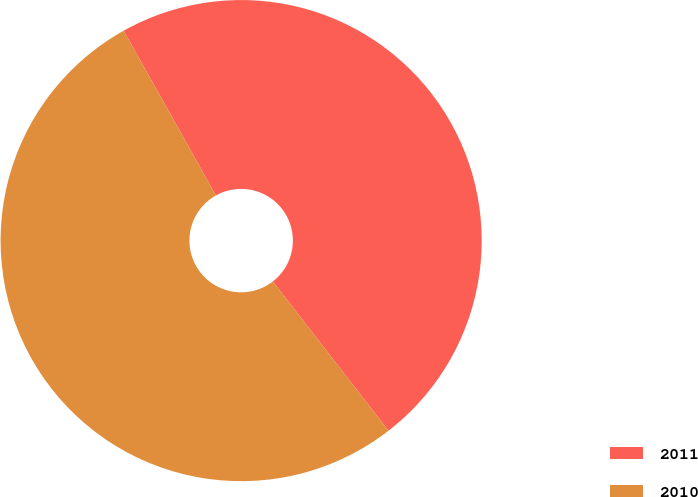Convert chart. <chart><loc_0><loc_0><loc_500><loc_500><pie_chart><fcel>2011<fcel>2010<nl><fcel>47.63%<fcel>52.37%<nl></chart> 